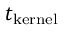Convert formula to latex. <formula><loc_0><loc_0><loc_500><loc_500>t _ { k e r n e l }</formula> 